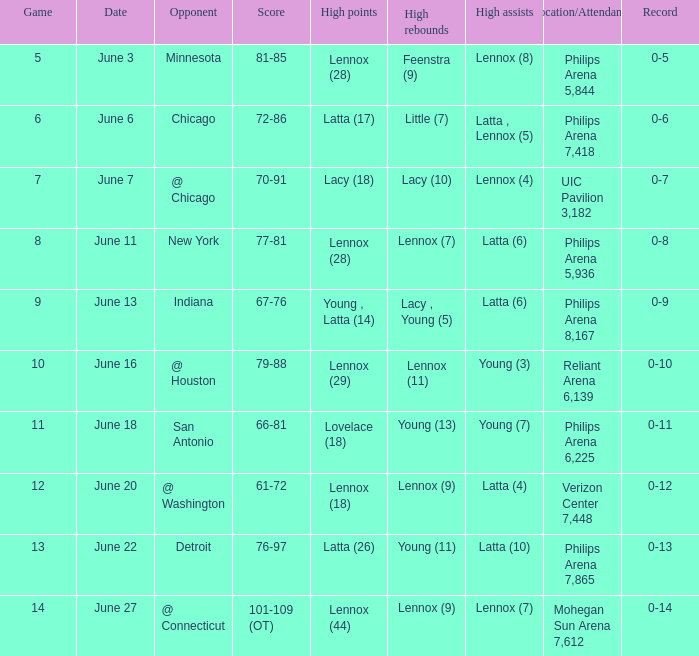What stadium hosted the June 7 game and how many visitors were there? UIC Pavilion 3,182. 